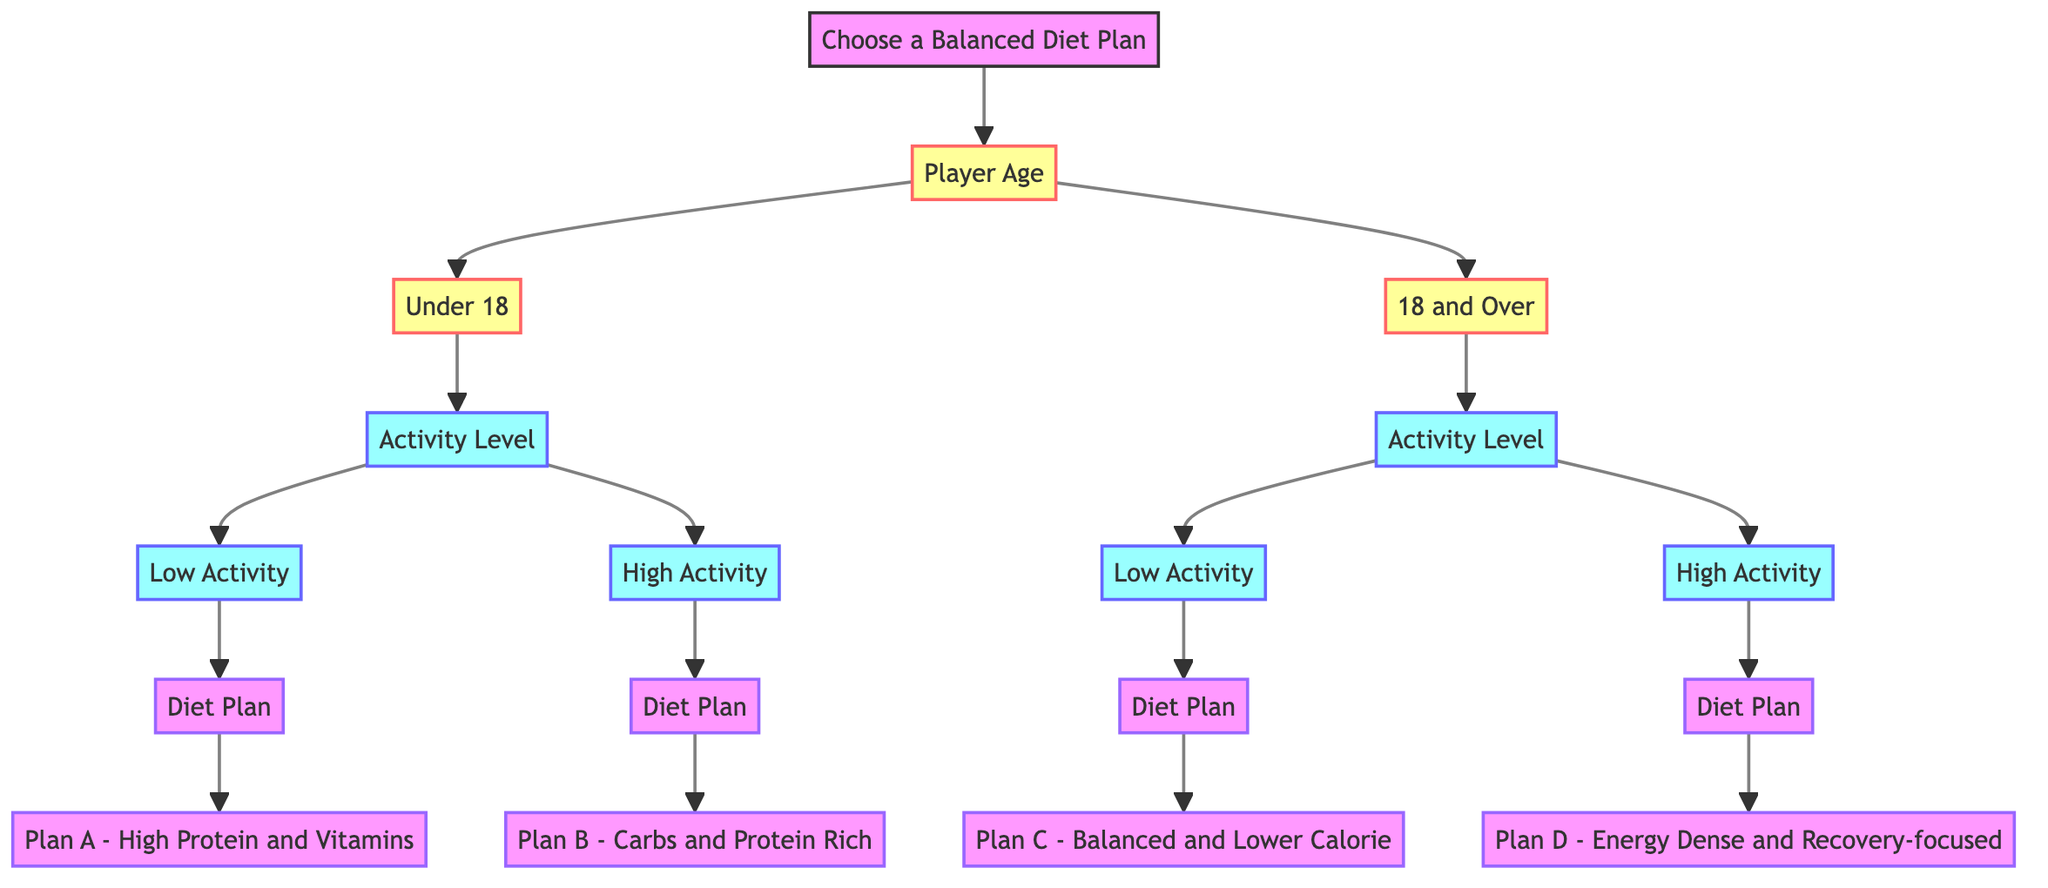What are the age categories in the diagram? The diagram presents two age categories: "Under 18" and "18 and Over." These categories help guide the choice of diet plans based on age.
Answer: Under 18, 18 and Over What is the diet plan for a player aged Under 18 with Low Activity? According to the diagram, if a player is under 18 and has low activity, the diet plan recommended is "Plan A - High Protein and Vitamins." This plan focuses on nutritional intake suitable for their activity level.
Answer: Plan A - High Protein and Vitamins How many diet plans are listed for players aged 18 and Over? The diagram shows two diet plans available for players aged 18 and over: Plan C (Low Activity) and Plan D (High Activity). This reflects the nutritional strategy for the different activity levels in this age group.
Answer: 2 Which diet plan is associated with High Activity for players aged 18 and Over? The diagram indicates that for players 18 and over with high activity, the recommended diet plan is "Plan D - Energy Dense and Recovery-focused." This plan supports the higher energy needs of active players.
Answer: Plan D - Energy Dense and Recovery-focused What is the common theme of diet plans for Low Activity players of all ages? Both Low Activity categories for under 18 and 18 and over suggest diet plans that are more balanced and lower in calories, emphasizing nutrient-rich foods rather than energy-dense options. This supports the lower energy needs for less active individuals.
Answer: Balanced and Lower Calorie What nutritional element is emphasized in "Plan B - Carbs and Protein Rich"? "Plan B - Carbs and Protein Rich" emphasizes carbohydrates and protein, which are essential for energy and muscle repair, especially for young players with high activity levels. This plan is designed to meet their training demands.
Answer: Carbs and Protein How does the diagram differentiate diet plans based on activity levels? The diagram organizes diet plans based on two primary activity levels: Low Activity and High Activity. Each age group has specific recommendations tailored for both activity levels, illustrating the need for different nutritional approaches based on how active the player is.
Answer: By Activity Levels What is the description of "Plan C - Balanced and Lower Calorie"? "Plan C - Balanced and Lower Calorie" is described as including quinoa, legumes, greens, some lean meat, and low-fat dairy, reflecting its focus on balanced nutrition with lower calorie content for less active adults.
Answer: Includes quinoa, legumes, greens, some lean meat, and low-fat dairy 